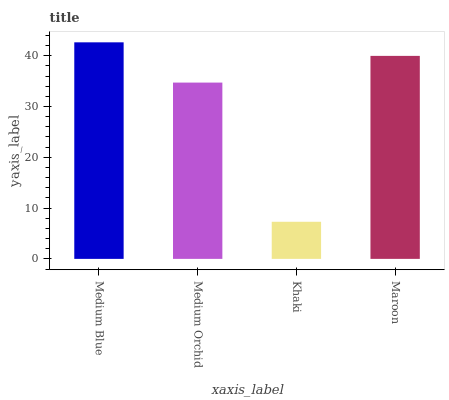Is Khaki the minimum?
Answer yes or no. Yes. Is Medium Blue the maximum?
Answer yes or no. Yes. Is Medium Orchid the minimum?
Answer yes or no. No. Is Medium Orchid the maximum?
Answer yes or no. No. Is Medium Blue greater than Medium Orchid?
Answer yes or no. Yes. Is Medium Orchid less than Medium Blue?
Answer yes or no. Yes. Is Medium Orchid greater than Medium Blue?
Answer yes or no. No. Is Medium Blue less than Medium Orchid?
Answer yes or no. No. Is Maroon the high median?
Answer yes or no. Yes. Is Medium Orchid the low median?
Answer yes or no. Yes. Is Medium Blue the high median?
Answer yes or no. No. Is Khaki the low median?
Answer yes or no. No. 